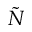Convert formula to latex. <formula><loc_0><loc_0><loc_500><loc_500>\tilde { N }</formula> 